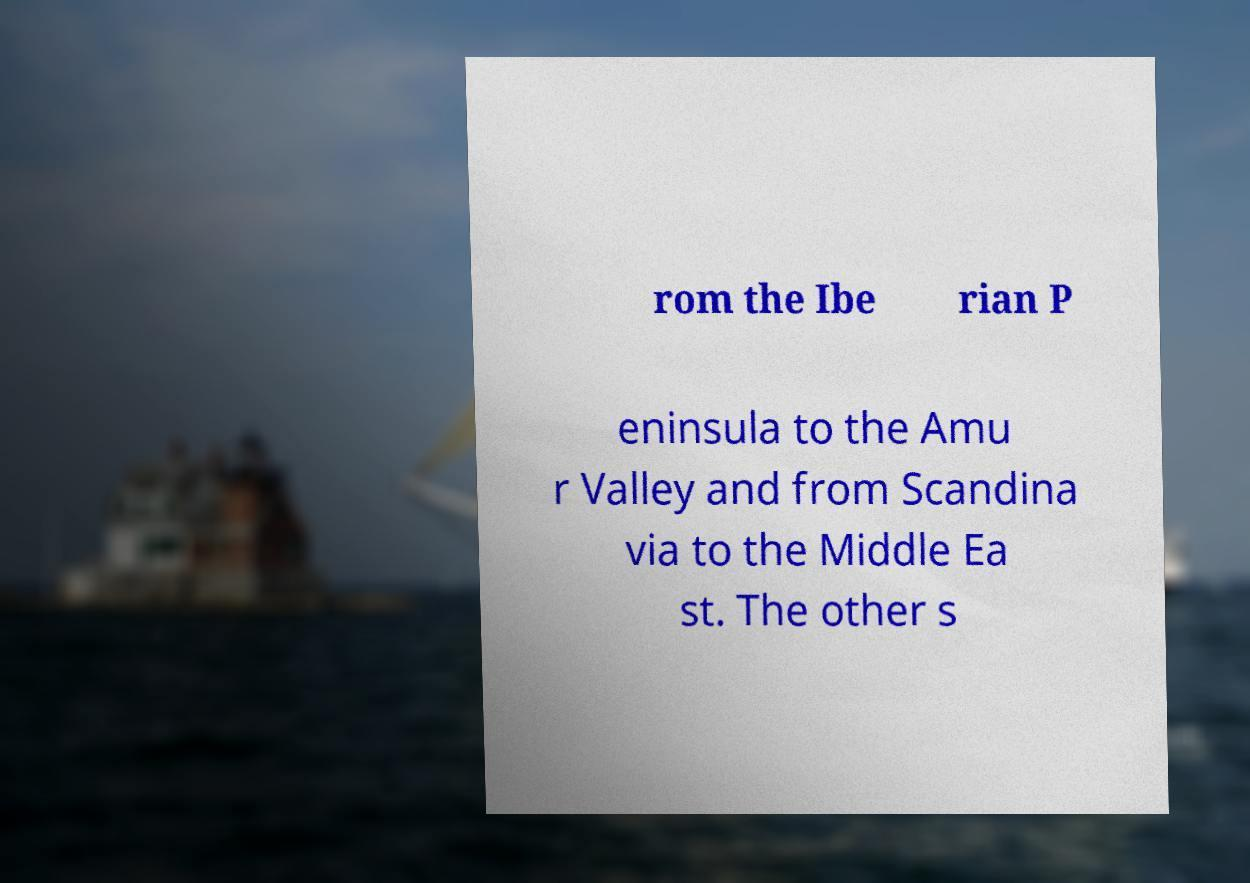Can you accurately transcribe the text from the provided image for me? rom the Ibe rian P eninsula to the Amu r Valley and from Scandina via to the Middle Ea st. The other s 